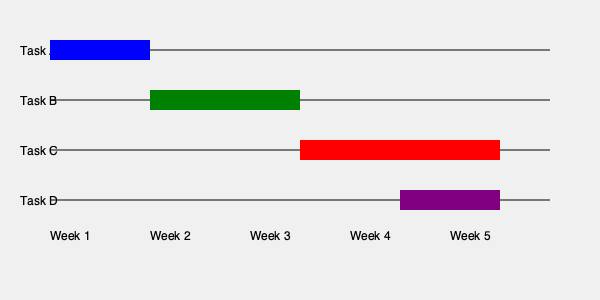Based on the Gantt chart shown, which task has the longest duration, and how many weeks does it last? To determine the task with the longest duration and its length in weeks, we need to analyze each task's timeline:

1. Task A (blue): Starts at the beginning of Week 1 and ends at the beginning of Week 2, lasting 1 week.
2. Task B (green): Starts at the beginning of Week 2 and ends halfway through Week 3, lasting 1.5 weeks.
3. Task C (red): Starts at the beginning of Week 3 and ends at the end of Week 5, lasting 2 weeks.
4. Task D (purple): Starts halfway through Week 4 and ends at the end of Week 5, lasting 1 week.

Comparing the durations:
Task A: 1 week
Task B: 1.5 weeks
Task C: 2 weeks
Task D: 1 week

Task C has the longest duration at 2 weeks.
Answer: Task C, 2 weeks 